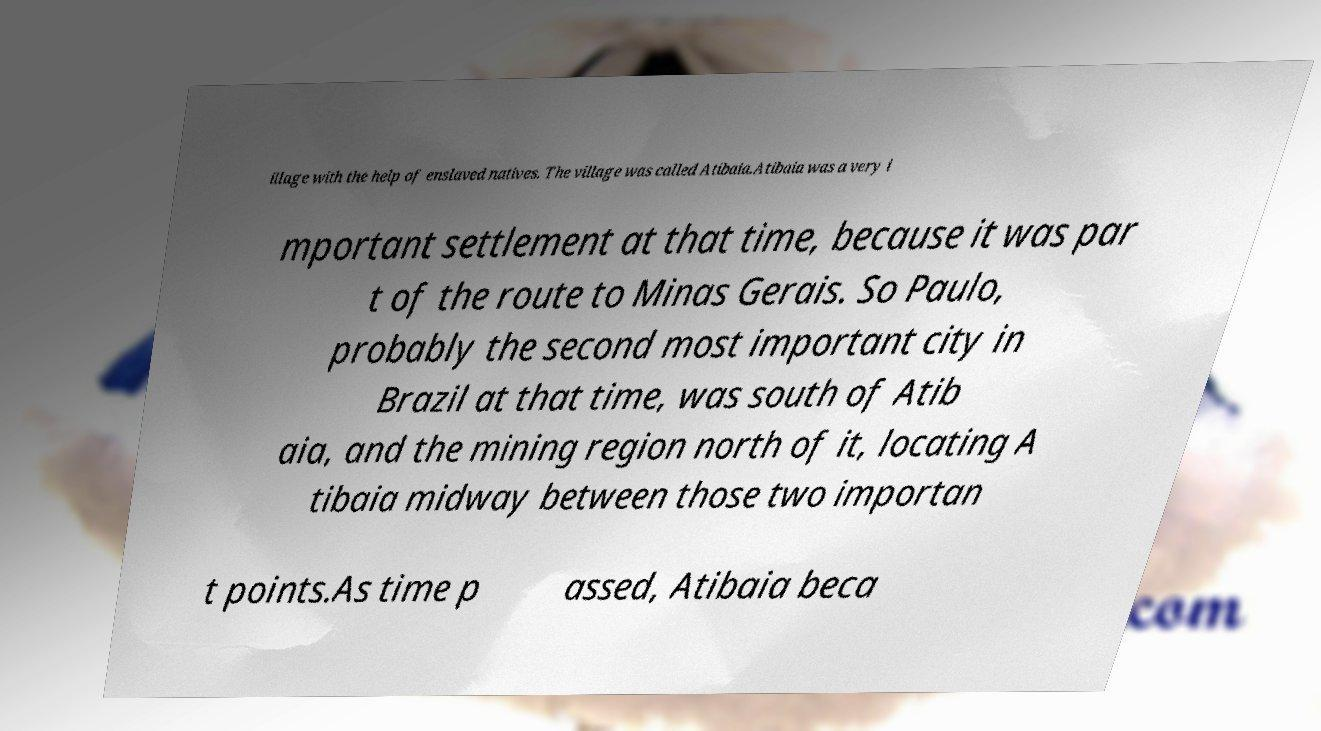For documentation purposes, I need the text within this image transcribed. Could you provide that? illage with the help of enslaved natives. The village was called Atibaia.Atibaia was a very i mportant settlement at that time, because it was par t of the route to Minas Gerais. So Paulo, probably the second most important city in Brazil at that time, was south of Atib aia, and the mining region north of it, locating A tibaia midway between those two importan t points.As time p assed, Atibaia beca 